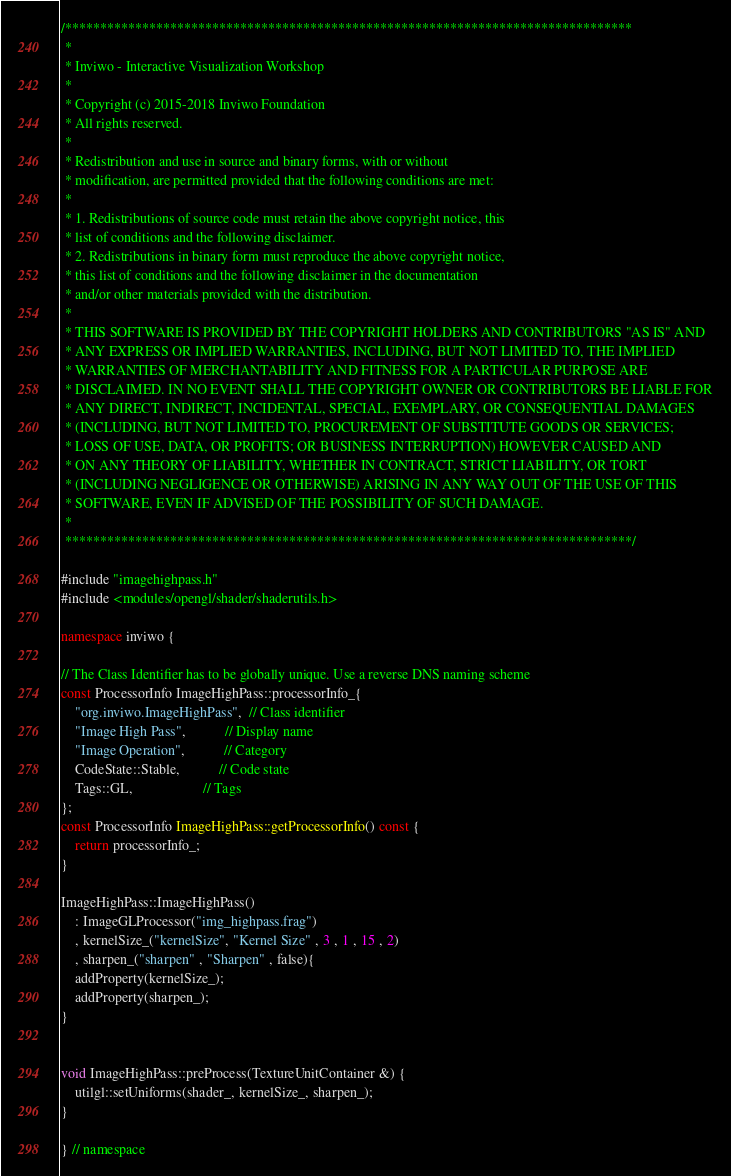Convert code to text. <code><loc_0><loc_0><loc_500><loc_500><_C++_>/*********************************************************************************
 *
 * Inviwo - Interactive Visualization Workshop
 *
 * Copyright (c) 2015-2018 Inviwo Foundation
 * All rights reserved.
 *
 * Redistribution and use in source and binary forms, with or without
 * modification, are permitted provided that the following conditions are met:
 *
 * 1. Redistributions of source code must retain the above copyright notice, this
 * list of conditions and the following disclaimer.
 * 2. Redistributions in binary form must reproduce the above copyright notice,
 * this list of conditions and the following disclaimer in the documentation
 * and/or other materials provided with the distribution.
 *
 * THIS SOFTWARE IS PROVIDED BY THE COPYRIGHT HOLDERS AND CONTRIBUTORS "AS IS" AND
 * ANY EXPRESS OR IMPLIED WARRANTIES, INCLUDING, BUT NOT LIMITED TO, THE IMPLIED
 * WARRANTIES OF MERCHANTABILITY AND FITNESS FOR A PARTICULAR PURPOSE ARE
 * DISCLAIMED. IN NO EVENT SHALL THE COPYRIGHT OWNER OR CONTRIBUTORS BE LIABLE FOR
 * ANY DIRECT, INDIRECT, INCIDENTAL, SPECIAL, EXEMPLARY, OR CONSEQUENTIAL DAMAGES
 * (INCLUDING, BUT NOT LIMITED TO, PROCUREMENT OF SUBSTITUTE GOODS OR SERVICES;
 * LOSS OF USE, DATA, OR PROFITS; OR BUSINESS INTERRUPTION) HOWEVER CAUSED AND
 * ON ANY THEORY OF LIABILITY, WHETHER IN CONTRACT, STRICT LIABILITY, OR TORT
 * (INCLUDING NEGLIGENCE OR OTHERWISE) ARISING IN ANY WAY OUT OF THE USE OF THIS
 * SOFTWARE, EVEN IF ADVISED OF THE POSSIBILITY OF SUCH DAMAGE.
 *
 *********************************************************************************/

#include "imagehighpass.h"
#include <modules/opengl/shader/shaderutils.h>

namespace inviwo {

// The Class Identifier has to be globally unique. Use a reverse DNS naming scheme
const ProcessorInfo ImageHighPass::processorInfo_{
    "org.inviwo.ImageHighPass",  // Class identifier
    "Image High Pass",           // Display name
    "Image Operation",           // Category
    CodeState::Stable,           // Code state
    Tags::GL,                    // Tags
};
const ProcessorInfo ImageHighPass::getProcessorInfo() const {
    return processorInfo_;
}

ImageHighPass::ImageHighPass()
    : ImageGLProcessor("img_highpass.frag")
    , kernelSize_("kernelSize", "Kernel Size" , 3 , 1 , 15 , 2) 
    , sharpen_("sharpen" , "Sharpen" , false){
    addProperty(kernelSize_);
    addProperty(sharpen_);
}


void ImageHighPass::preProcess(TextureUnitContainer &) {
    utilgl::setUniforms(shader_, kernelSize_, sharpen_);
}

} // namespace


</code> 